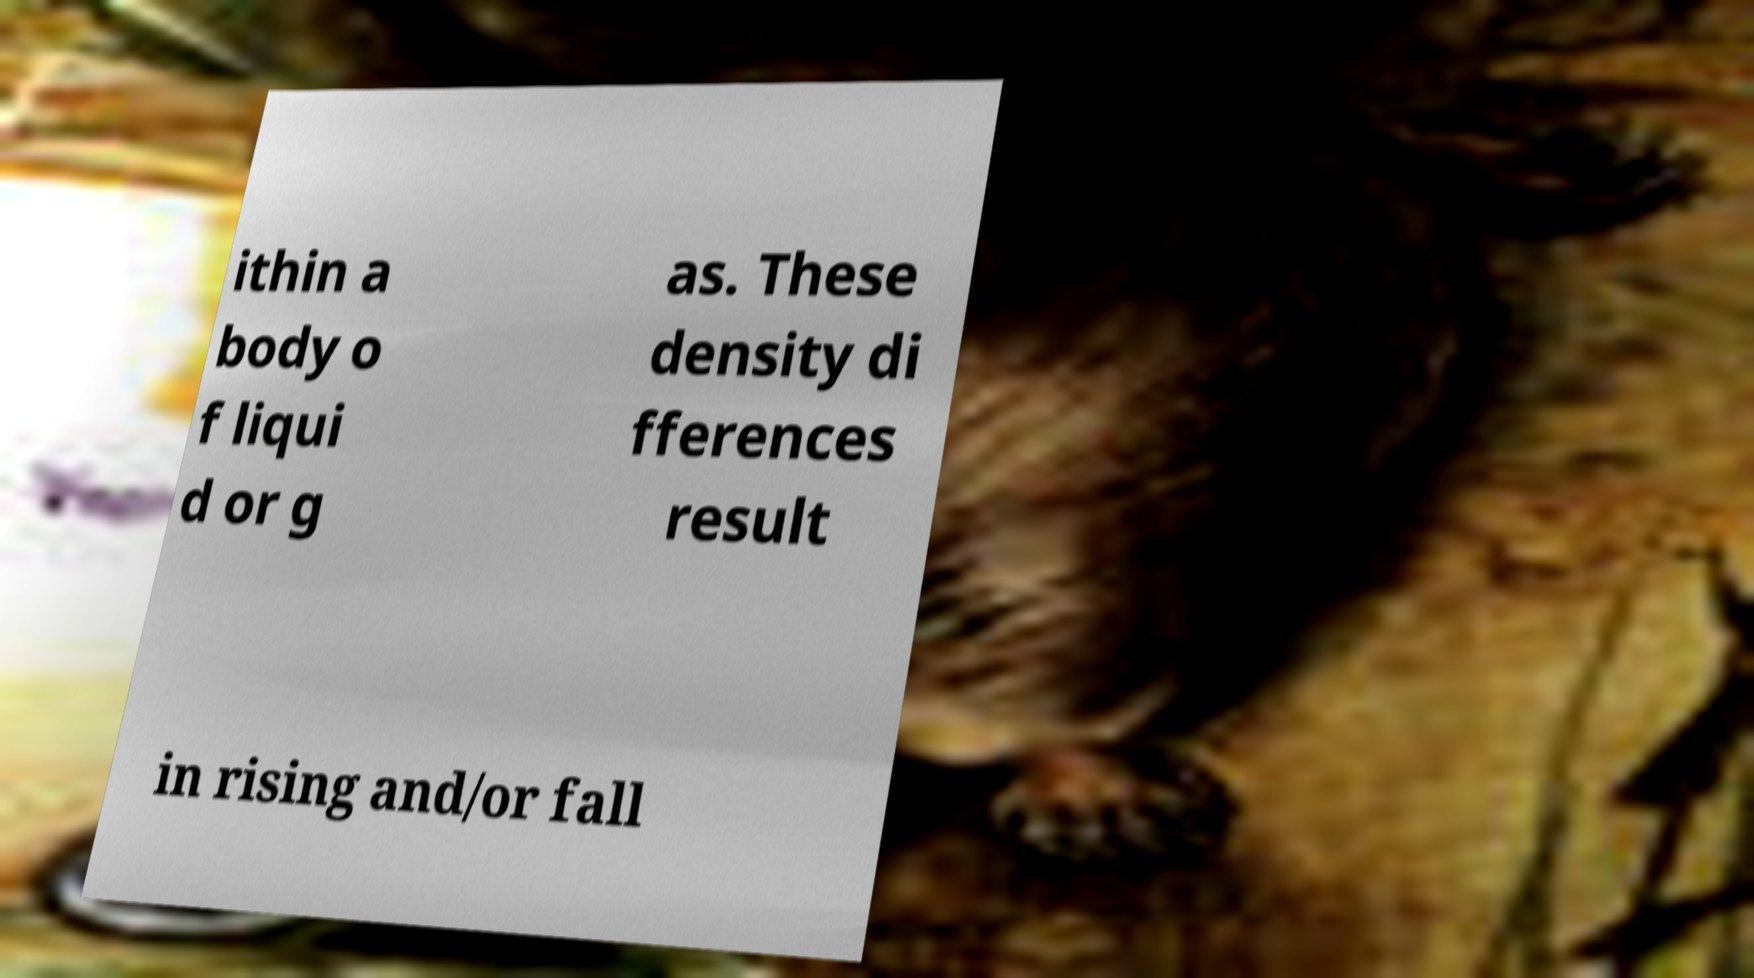Please identify and transcribe the text found in this image. ithin a body o f liqui d or g as. These density di fferences result in rising and/or fall 